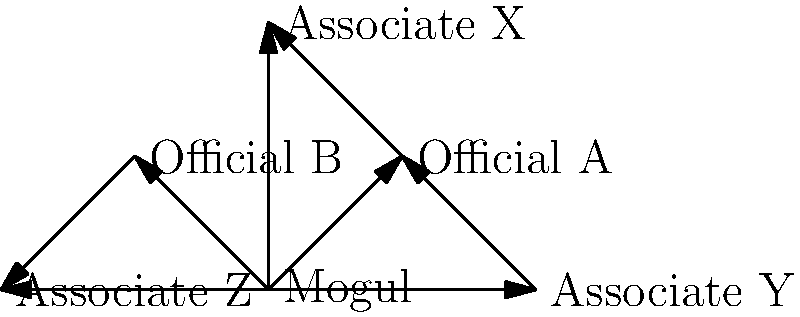Based on the relationship diagram, which business associate appears to have the most direct connections to local officials, potentially indicating a higher risk of conflicts of interest? To determine which business associate has the most direct connections to local officials, we need to analyze the diagram step-by-step:

1. Identify the business associates:
   - Associate X
   - Associate Y
   - Associate Z

2. Identify the local officials:
   - Official A
   - Official B

3. Count direct connections between associates and officials:
   - Associate X is directly connected to Official A
   - Associate Y is directly connected to Official A
   - Associate Z is directly connected to Official B

4. Compare the number of connections:
   - Associate X: 1 connection
   - Associate Y: 1 connection
   - Associate Z: 1 connection

5. Analyze indirect connections:
   - Associate Y has an indirect connection to Official A through the Mogul
   - Associate X and Associate Z have no additional indirect connections

6. Conclusion:
   While all associates have one direct connection, Associate Y has an additional indirect connection, potentially indicating a higher risk of conflicts of interest.
Answer: Associate Y 